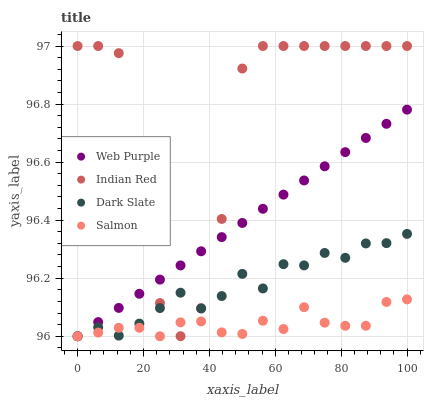Does Salmon have the minimum area under the curve?
Answer yes or no. Yes. Does Indian Red have the maximum area under the curve?
Answer yes or no. Yes. Does Web Purple have the minimum area under the curve?
Answer yes or no. No. Does Web Purple have the maximum area under the curve?
Answer yes or no. No. Is Web Purple the smoothest?
Answer yes or no. Yes. Is Indian Red the roughest?
Answer yes or no. Yes. Is Salmon the smoothest?
Answer yes or no. No. Is Salmon the roughest?
Answer yes or no. No. Does Dark Slate have the lowest value?
Answer yes or no. Yes. Does Indian Red have the lowest value?
Answer yes or no. No. Does Indian Red have the highest value?
Answer yes or no. Yes. Does Web Purple have the highest value?
Answer yes or no. No. Does Web Purple intersect Dark Slate?
Answer yes or no. Yes. Is Web Purple less than Dark Slate?
Answer yes or no. No. Is Web Purple greater than Dark Slate?
Answer yes or no. No. 